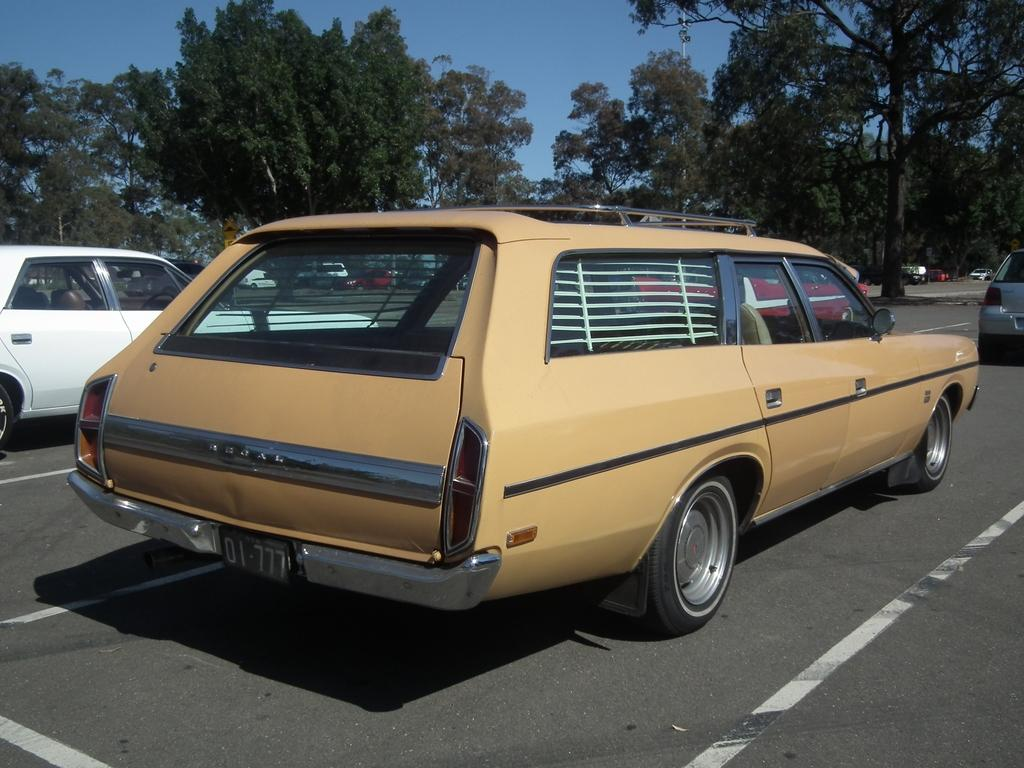What color is the car that is the main subject of the image? There is a yellow car in the image. Where is the yellow car located? The yellow car is on the road. What other car can be seen in the image? There is a white car on the left side of the image. What can be seen in the background of the image? There are trees and the sky visible in the background of the image. What type of pancake is being served at the level crossing in the image? There is no level crossing or pancake present in the image. 